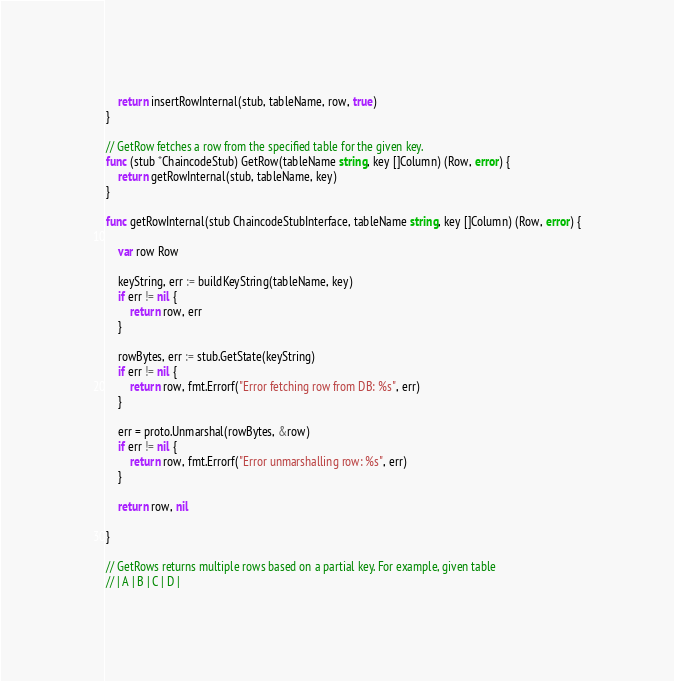Convert code to text. <code><loc_0><loc_0><loc_500><loc_500><_Go_>	return insertRowInternal(stub, tableName, row, true)
}

// GetRow fetches a row from the specified table for the given key.
func (stub *ChaincodeStub) GetRow(tableName string, key []Column) (Row, error) {
	return getRowInternal(stub, tableName, key)
}

func getRowInternal(stub ChaincodeStubInterface, tableName string, key []Column) (Row, error) {

	var row Row

	keyString, err := buildKeyString(tableName, key)
	if err != nil {
		return row, err
	}

	rowBytes, err := stub.GetState(keyString)
	if err != nil {
		return row, fmt.Errorf("Error fetching row from DB: %s", err)
	}

	err = proto.Unmarshal(rowBytes, &row)
	if err != nil {
		return row, fmt.Errorf("Error unmarshalling row: %s", err)
	}

	return row, nil

}

// GetRows returns multiple rows based on a partial key. For example, given table
// | A | B | C | D |</code> 